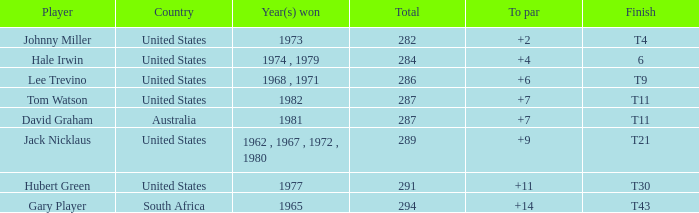WHAT IS THE TOTAL, OF A TO PAR FOR HUBERT GREEN, AND A TOTAL LARGER THAN 291? 0.0. 